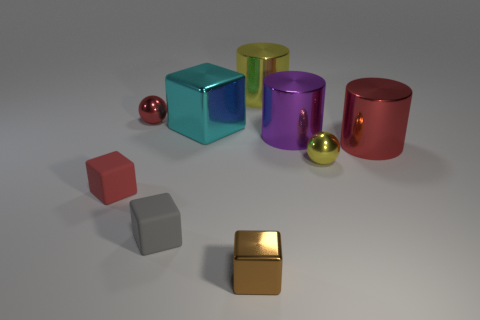Subtract all spheres. How many objects are left? 7 Add 8 small gray matte cubes. How many small gray matte cubes are left? 9 Add 3 large red metal cylinders. How many large red metal cylinders exist? 4 Subtract 0 brown spheres. How many objects are left? 9 Subtract all small red cubes. Subtract all small cubes. How many objects are left? 5 